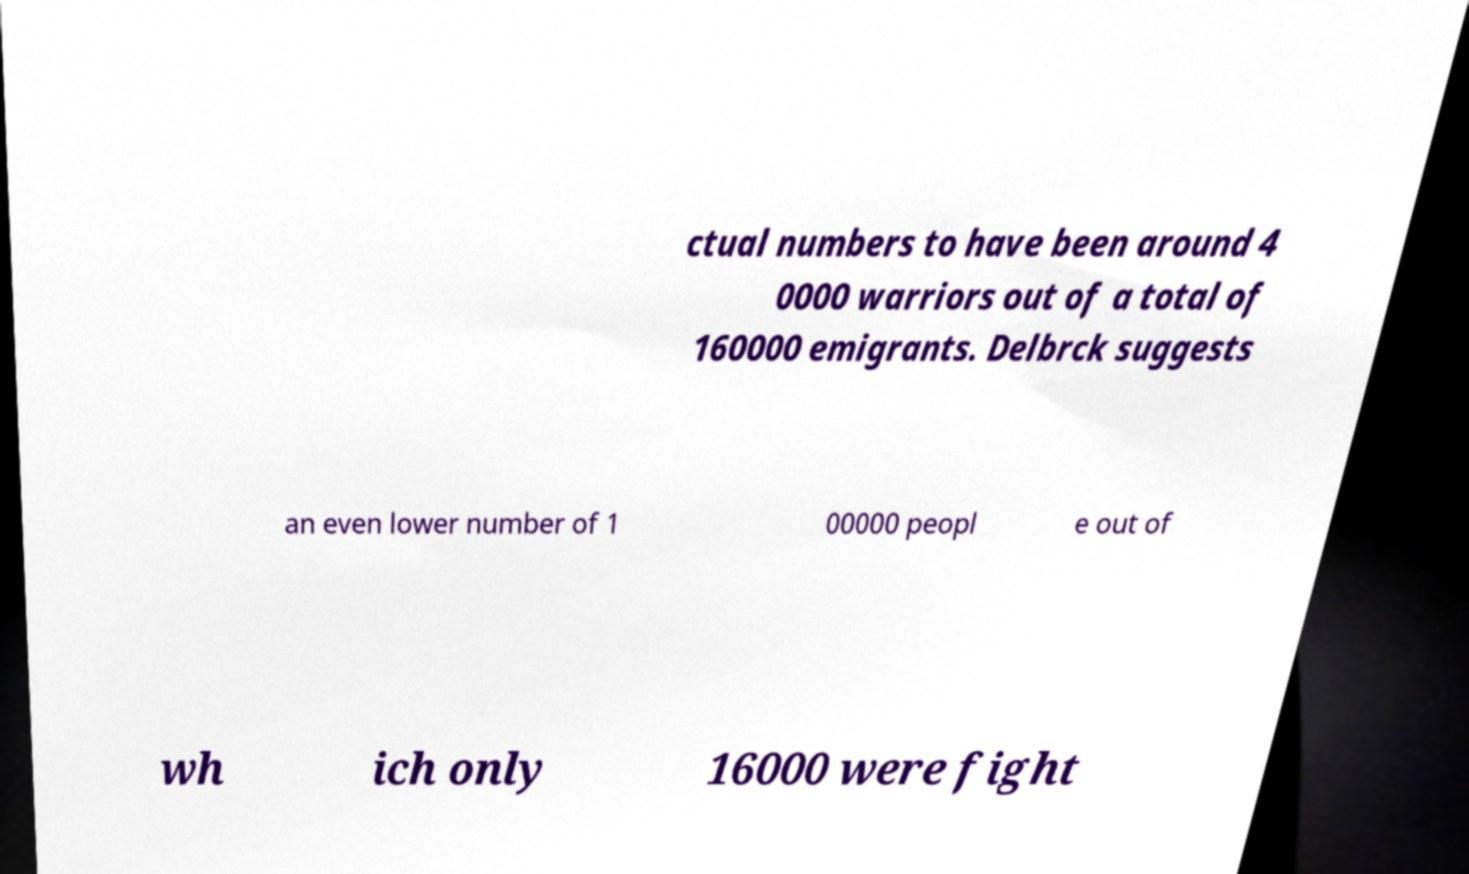Can you read and provide the text displayed in the image?This photo seems to have some interesting text. Can you extract and type it out for me? ctual numbers to have been around 4 0000 warriors out of a total of 160000 emigrants. Delbrck suggests an even lower number of 1 00000 peopl e out of wh ich only 16000 were fight 